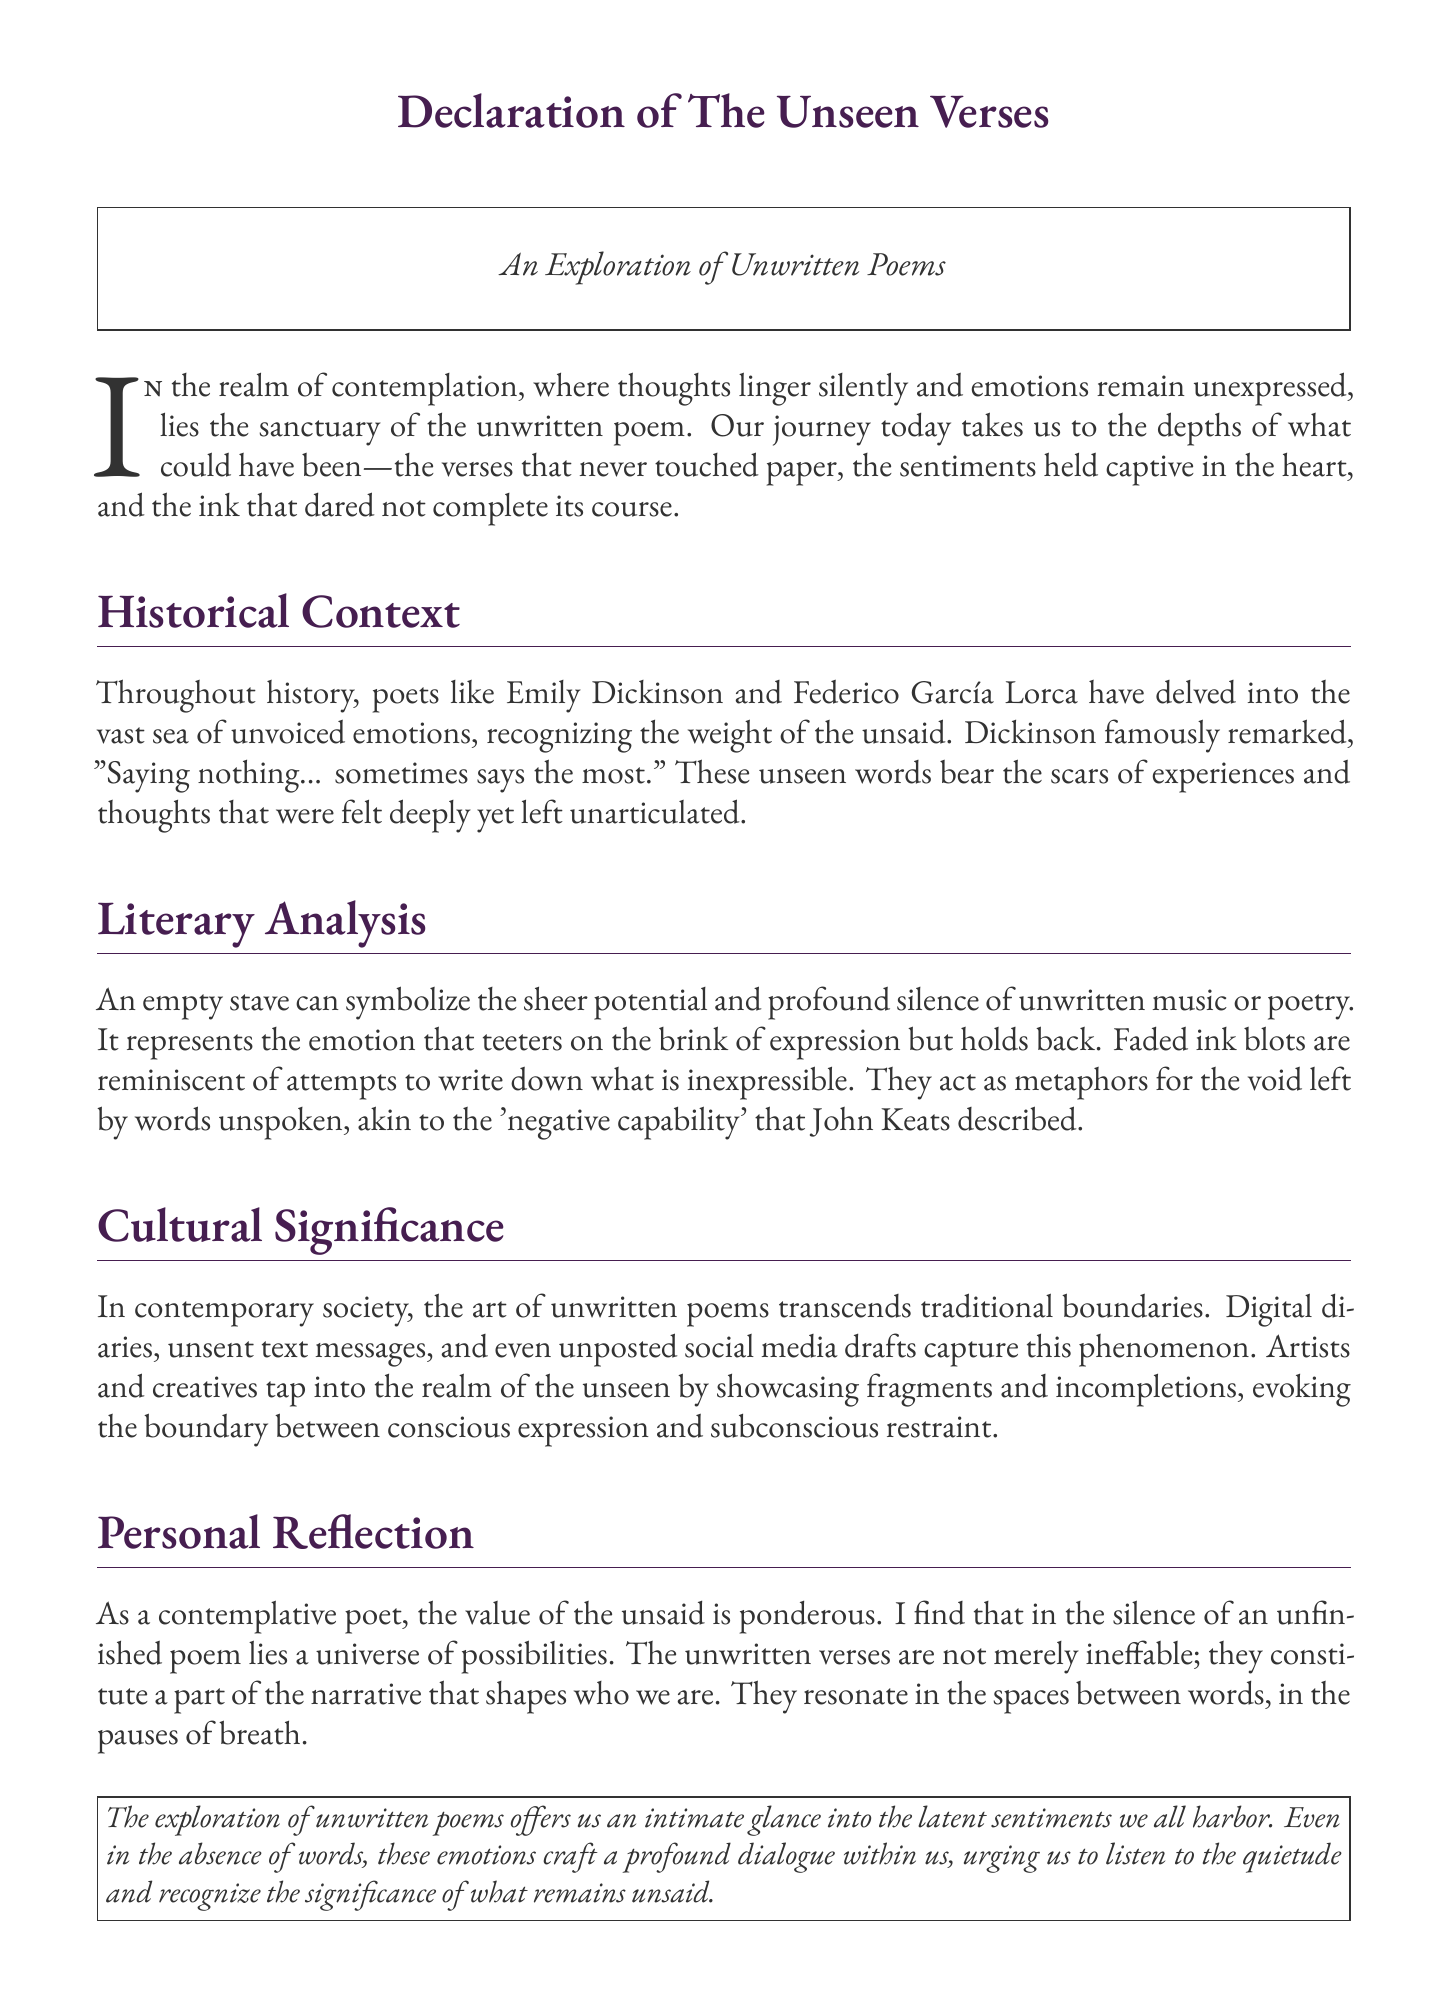What is the title of the document? The title of the document appears prominently at the top of the page.
Answer: Declaration of The Unseen Verses Who are two poets mentioned in the historical context? The document highlights poets who have explored unexpressed emotions, naming two specifically.
Answer: Emily Dickinson and Federico García Lorca What metaphor represents the void of unspoken words? The document discusses symbols that resonate with unwritten thoughts and emotions.
Answer: Faded ink blots What concept is described by John Keats in relation to unwritten poems? The document references a literary idea that connects to the theme of unexpressed emotions.
Answer: Negative capability What contemporary forms capture the art of unwritten poems? The document discusses modern expressions of unresolved emotions in various formats.
Answer: Digital diaries What is the emotional outlook on unwritten verses according to the poet's personal reflection? The document conveys a deep appreciation for the silent thoughts that shape our identities.
Answer: A universe of possibilities How does the declaration conclude? The document summarizes the exploration of unwritten poems and their significance.
Answer: An intimate glance into the latent sentiments 